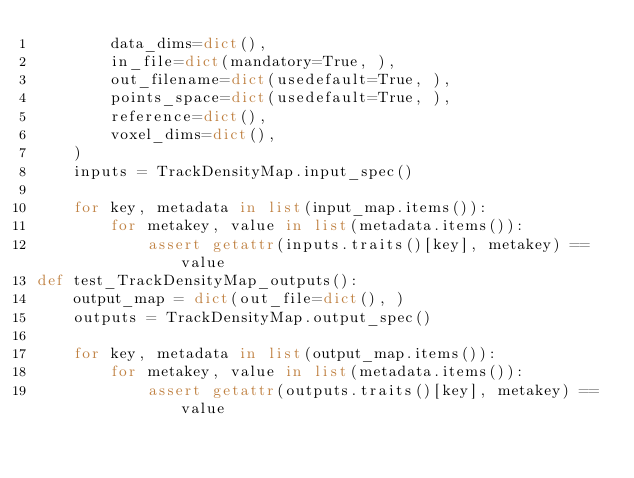<code> <loc_0><loc_0><loc_500><loc_500><_Python_>        data_dims=dict(),
        in_file=dict(mandatory=True, ),
        out_filename=dict(usedefault=True, ),
        points_space=dict(usedefault=True, ),
        reference=dict(),
        voxel_dims=dict(),
    )
    inputs = TrackDensityMap.input_spec()

    for key, metadata in list(input_map.items()):
        for metakey, value in list(metadata.items()):
            assert getattr(inputs.traits()[key], metakey) == value
def test_TrackDensityMap_outputs():
    output_map = dict(out_file=dict(), )
    outputs = TrackDensityMap.output_spec()

    for key, metadata in list(output_map.items()):
        for metakey, value in list(metadata.items()):
            assert getattr(outputs.traits()[key], metakey) == value
</code> 